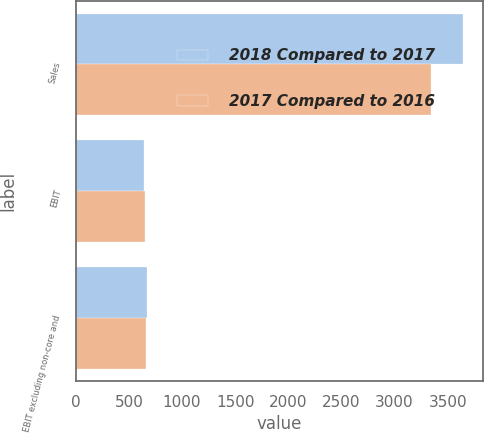Convert chart. <chart><loc_0><loc_0><loc_500><loc_500><stacked_bar_chart><ecel><fcel>Sales<fcel>EBIT<fcel>EBIT excluding non-core and<nl><fcel>2018 Compared to 2017<fcel>3647<fcel>639<fcel>671<nl><fcel>2017 Compared to 2016<fcel>3343<fcel>653<fcel>661<nl></chart> 